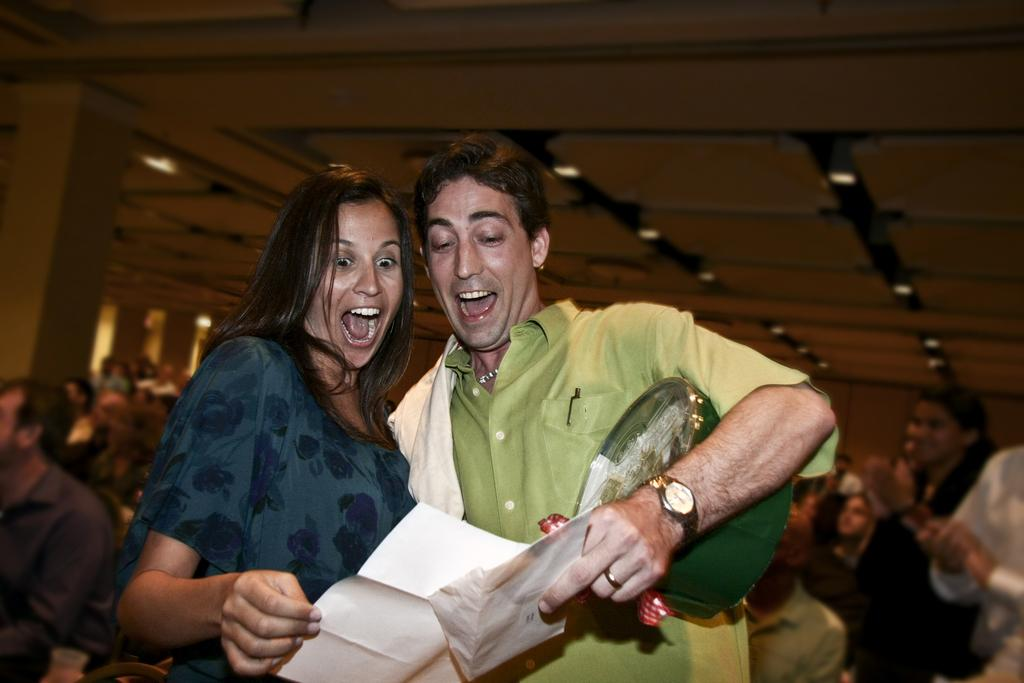How many people are present in the image? There are two people, a woman and a man, present in the image. What are the woman and man holding in the image? The woman and man are holding objects in the image. Can you describe the background of the image? The background of the image is blurred. What architectural features can be seen in the image? There is a wall, a pillar, and a ceiling visible in the image. What type of lighting is present in the image? There are lights present in the image. What type of branch can be seen growing from the woman's head in the image? There is no branch growing from the woman's head in the image. 